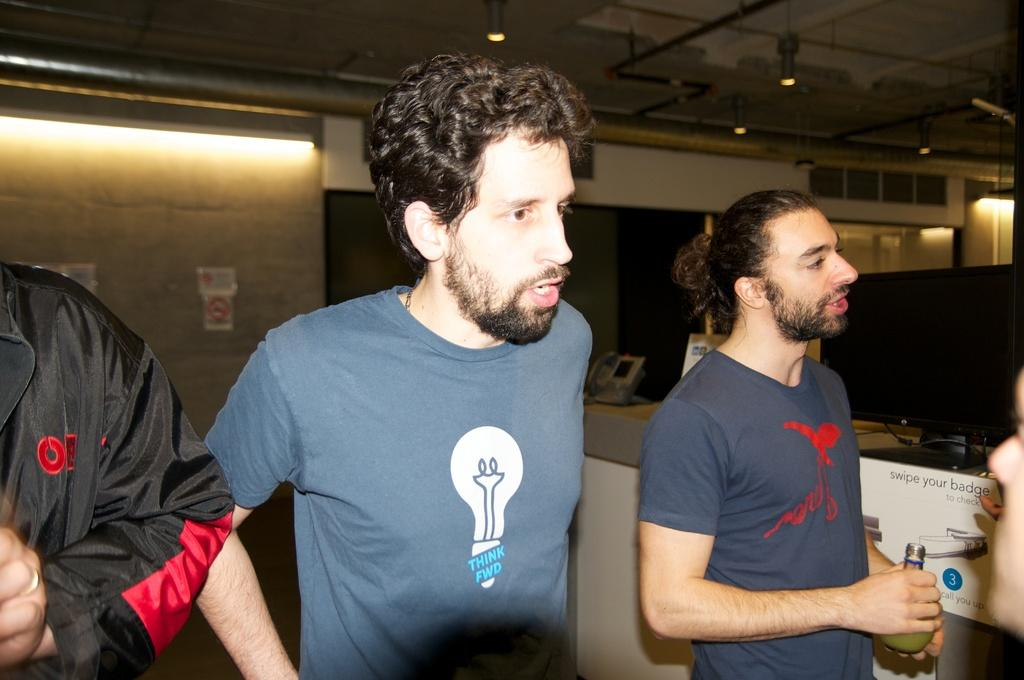<image>
Relay a brief, clear account of the picture shown. A man in a grey shirt next to a sign saying to swipe your badge to check 